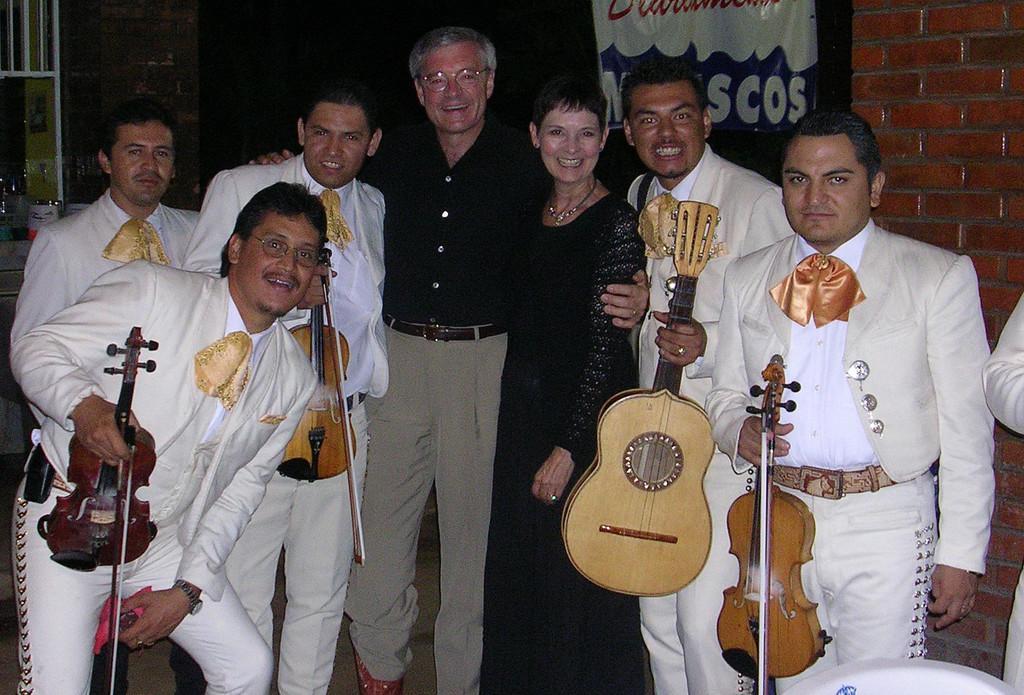Describe this image in one or two sentences. In this image a person is standing, beside to him there is a woman. At the right side of the image person is holding a violin. Person beside this woman is holding a guitar. At the backside of this image there is a red brick wall on which a banner is placed. 